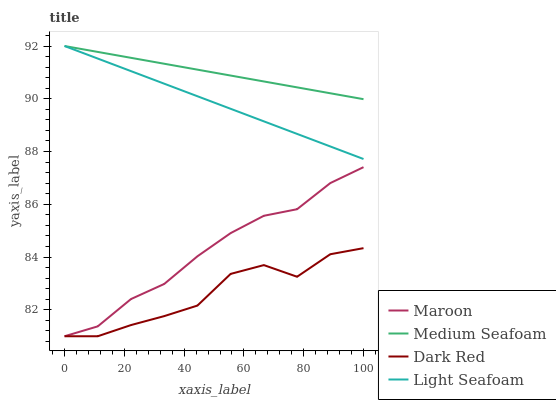Does Light Seafoam have the minimum area under the curve?
Answer yes or no. No. Does Light Seafoam have the maximum area under the curve?
Answer yes or no. No. Is Medium Seafoam the smoothest?
Answer yes or no. No. Is Medium Seafoam the roughest?
Answer yes or no. No. Does Light Seafoam have the lowest value?
Answer yes or no. No. Does Maroon have the highest value?
Answer yes or no. No. Is Maroon less than Light Seafoam?
Answer yes or no. Yes. Is Light Seafoam greater than Dark Red?
Answer yes or no. Yes. Does Maroon intersect Light Seafoam?
Answer yes or no. No. 